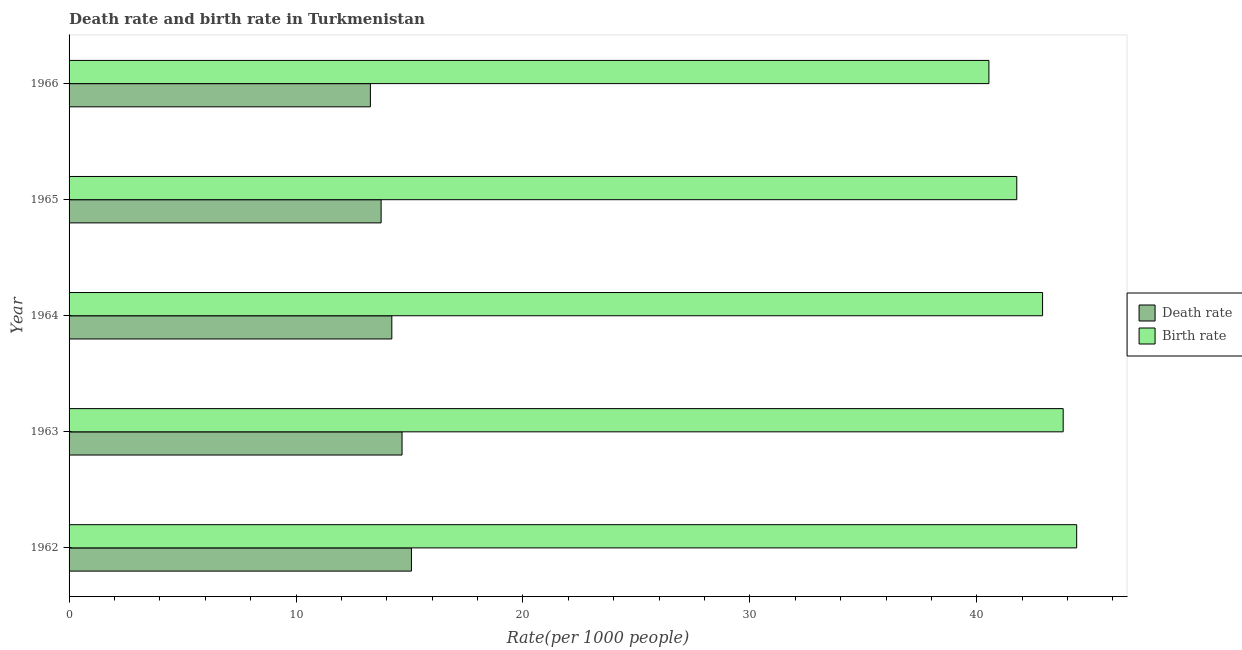How many groups of bars are there?
Make the answer very short. 5. How many bars are there on the 5th tick from the bottom?
Ensure brevity in your answer.  2. What is the label of the 3rd group of bars from the top?
Provide a short and direct response. 1964. What is the death rate in 1965?
Your answer should be compact. 13.75. Across all years, what is the maximum death rate?
Keep it short and to the point. 15.09. Across all years, what is the minimum birth rate?
Keep it short and to the point. 40.53. In which year was the death rate minimum?
Your answer should be compact. 1966. What is the total death rate in the graph?
Provide a short and direct response. 71.01. What is the difference between the death rate in 1963 and that in 1964?
Provide a succinct answer. 0.45. What is the difference between the death rate in 1962 and the birth rate in 1964?
Offer a very short reply. -27.81. What is the average death rate per year?
Your answer should be compact. 14.2. In the year 1965, what is the difference between the death rate and birth rate?
Your answer should be very brief. -28.01. In how many years, is the death rate greater than 42 ?
Ensure brevity in your answer.  0. What is the ratio of the death rate in 1965 to that in 1966?
Your answer should be very brief. 1.04. Is the birth rate in 1962 less than that in 1963?
Your response must be concise. No. Is the difference between the birth rate in 1962 and 1964 greater than the difference between the death rate in 1962 and 1964?
Offer a very short reply. Yes. What is the difference between the highest and the second highest birth rate?
Ensure brevity in your answer.  0.59. What is the difference between the highest and the lowest death rate?
Your response must be concise. 1.81. What does the 2nd bar from the top in 1966 represents?
Your response must be concise. Death rate. What does the 1st bar from the bottom in 1966 represents?
Make the answer very short. Death rate. How many bars are there?
Keep it short and to the point. 10. Are all the bars in the graph horizontal?
Provide a succinct answer. Yes. How many years are there in the graph?
Ensure brevity in your answer.  5. Does the graph contain any zero values?
Keep it short and to the point. No. Does the graph contain grids?
Offer a very short reply. No. How many legend labels are there?
Your response must be concise. 2. What is the title of the graph?
Your answer should be compact. Death rate and birth rate in Turkmenistan. Does "Investment in Transport" appear as one of the legend labels in the graph?
Provide a succinct answer. No. What is the label or title of the X-axis?
Your answer should be compact. Rate(per 1000 people). What is the Rate(per 1000 people) of Death rate in 1962?
Your answer should be very brief. 15.09. What is the Rate(per 1000 people) of Birth rate in 1962?
Keep it short and to the point. 44.4. What is the Rate(per 1000 people) in Death rate in 1963?
Keep it short and to the point. 14.67. What is the Rate(per 1000 people) of Birth rate in 1963?
Your response must be concise. 43.81. What is the Rate(per 1000 people) in Death rate in 1964?
Your answer should be compact. 14.22. What is the Rate(per 1000 people) in Birth rate in 1964?
Your answer should be compact. 42.9. What is the Rate(per 1000 people) of Death rate in 1965?
Provide a short and direct response. 13.75. What is the Rate(per 1000 people) of Birth rate in 1965?
Offer a very short reply. 41.76. What is the Rate(per 1000 people) of Death rate in 1966?
Ensure brevity in your answer.  13.28. What is the Rate(per 1000 people) in Birth rate in 1966?
Provide a short and direct response. 40.53. Across all years, what is the maximum Rate(per 1000 people) in Death rate?
Provide a short and direct response. 15.09. Across all years, what is the maximum Rate(per 1000 people) of Birth rate?
Your response must be concise. 44.4. Across all years, what is the minimum Rate(per 1000 people) in Death rate?
Provide a short and direct response. 13.28. Across all years, what is the minimum Rate(per 1000 people) in Birth rate?
Keep it short and to the point. 40.53. What is the total Rate(per 1000 people) of Death rate in the graph?
Provide a short and direct response. 71.01. What is the total Rate(per 1000 people) in Birth rate in the graph?
Give a very brief answer. 213.4. What is the difference between the Rate(per 1000 people) in Death rate in 1962 and that in 1963?
Ensure brevity in your answer.  0.41. What is the difference between the Rate(per 1000 people) in Birth rate in 1962 and that in 1963?
Offer a very short reply. 0.59. What is the difference between the Rate(per 1000 people) of Death rate in 1962 and that in 1964?
Your response must be concise. 0.86. What is the difference between the Rate(per 1000 people) in Birth rate in 1962 and that in 1964?
Offer a very short reply. 1.5. What is the difference between the Rate(per 1000 people) in Death rate in 1962 and that in 1965?
Provide a succinct answer. 1.34. What is the difference between the Rate(per 1000 people) in Birth rate in 1962 and that in 1965?
Your answer should be compact. 2.64. What is the difference between the Rate(per 1000 people) in Death rate in 1962 and that in 1966?
Offer a terse response. 1.81. What is the difference between the Rate(per 1000 people) in Birth rate in 1962 and that in 1966?
Make the answer very short. 3.87. What is the difference between the Rate(per 1000 people) in Death rate in 1963 and that in 1964?
Give a very brief answer. 0.45. What is the difference between the Rate(per 1000 people) of Birth rate in 1963 and that in 1964?
Make the answer very short. 0.91. What is the difference between the Rate(per 1000 people) of Death rate in 1963 and that in 1965?
Provide a short and direct response. 0.92. What is the difference between the Rate(per 1000 people) in Birth rate in 1963 and that in 1965?
Your answer should be compact. 2.04. What is the difference between the Rate(per 1000 people) in Death rate in 1963 and that in 1966?
Provide a succinct answer. 1.4. What is the difference between the Rate(per 1000 people) in Birth rate in 1963 and that in 1966?
Your answer should be compact. 3.27. What is the difference between the Rate(per 1000 people) in Death rate in 1964 and that in 1965?
Give a very brief answer. 0.47. What is the difference between the Rate(per 1000 people) of Birth rate in 1964 and that in 1965?
Your response must be concise. 1.14. What is the difference between the Rate(per 1000 people) of Death rate in 1964 and that in 1966?
Your answer should be very brief. 0.94. What is the difference between the Rate(per 1000 people) of Birth rate in 1964 and that in 1966?
Offer a very short reply. 2.37. What is the difference between the Rate(per 1000 people) in Death rate in 1965 and that in 1966?
Provide a short and direct response. 0.47. What is the difference between the Rate(per 1000 people) in Birth rate in 1965 and that in 1966?
Keep it short and to the point. 1.23. What is the difference between the Rate(per 1000 people) of Death rate in 1962 and the Rate(per 1000 people) of Birth rate in 1963?
Give a very brief answer. -28.72. What is the difference between the Rate(per 1000 people) in Death rate in 1962 and the Rate(per 1000 people) in Birth rate in 1964?
Offer a very short reply. -27.81. What is the difference between the Rate(per 1000 people) of Death rate in 1962 and the Rate(per 1000 people) of Birth rate in 1965?
Provide a succinct answer. -26.68. What is the difference between the Rate(per 1000 people) of Death rate in 1962 and the Rate(per 1000 people) of Birth rate in 1966?
Provide a succinct answer. -25.45. What is the difference between the Rate(per 1000 people) of Death rate in 1963 and the Rate(per 1000 people) of Birth rate in 1964?
Keep it short and to the point. -28.23. What is the difference between the Rate(per 1000 people) in Death rate in 1963 and the Rate(per 1000 people) in Birth rate in 1965?
Ensure brevity in your answer.  -27.09. What is the difference between the Rate(per 1000 people) of Death rate in 1963 and the Rate(per 1000 people) of Birth rate in 1966?
Give a very brief answer. -25.86. What is the difference between the Rate(per 1000 people) of Death rate in 1964 and the Rate(per 1000 people) of Birth rate in 1965?
Ensure brevity in your answer.  -27.54. What is the difference between the Rate(per 1000 people) in Death rate in 1964 and the Rate(per 1000 people) in Birth rate in 1966?
Ensure brevity in your answer.  -26.31. What is the difference between the Rate(per 1000 people) in Death rate in 1965 and the Rate(per 1000 people) in Birth rate in 1966?
Your answer should be very brief. -26.78. What is the average Rate(per 1000 people) in Death rate per year?
Give a very brief answer. 14.2. What is the average Rate(per 1000 people) of Birth rate per year?
Keep it short and to the point. 42.68. In the year 1962, what is the difference between the Rate(per 1000 people) of Death rate and Rate(per 1000 people) of Birth rate?
Provide a succinct answer. -29.32. In the year 1963, what is the difference between the Rate(per 1000 people) in Death rate and Rate(per 1000 people) in Birth rate?
Provide a short and direct response. -29.13. In the year 1964, what is the difference between the Rate(per 1000 people) in Death rate and Rate(per 1000 people) in Birth rate?
Provide a succinct answer. -28.68. In the year 1965, what is the difference between the Rate(per 1000 people) in Death rate and Rate(per 1000 people) in Birth rate?
Give a very brief answer. -28.01. In the year 1966, what is the difference between the Rate(per 1000 people) in Death rate and Rate(per 1000 people) in Birth rate?
Give a very brief answer. -27.26. What is the ratio of the Rate(per 1000 people) of Death rate in 1962 to that in 1963?
Give a very brief answer. 1.03. What is the ratio of the Rate(per 1000 people) in Birth rate in 1962 to that in 1963?
Offer a very short reply. 1.01. What is the ratio of the Rate(per 1000 people) in Death rate in 1962 to that in 1964?
Your answer should be compact. 1.06. What is the ratio of the Rate(per 1000 people) in Birth rate in 1962 to that in 1964?
Your response must be concise. 1.03. What is the ratio of the Rate(per 1000 people) of Death rate in 1962 to that in 1965?
Provide a succinct answer. 1.1. What is the ratio of the Rate(per 1000 people) of Birth rate in 1962 to that in 1965?
Keep it short and to the point. 1.06. What is the ratio of the Rate(per 1000 people) in Death rate in 1962 to that in 1966?
Provide a short and direct response. 1.14. What is the ratio of the Rate(per 1000 people) in Birth rate in 1962 to that in 1966?
Your answer should be very brief. 1.1. What is the ratio of the Rate(per 1000 people) of Death rate in 1963 to that in 1964?
Your response must be concise. 1.03. What is the ratio of the Rate(per 1000 people) in Birth rate in 1963 to that in 1964?
Keep it short and to the point. 1.02. What is the ratio of the Rate(per 1000 people) in Death rate in 1963 to that in 1965?
Your answer should be compact. 1.07. What is the ratio of the Rate(per 1000 people) in Birth rate in 1963 to that in 1965?
Your answer should be compact. 1.05. What is the ratio of the Rate(per 1000 people) in Death rate in 1963 to that in 1966?
Provide a succinct answer. 1.11. What is the ratio of the Rate(per 1000 people) of Birth rate in 1963 to that in 1966?
Ensure brevity in your answer.  1.08. What is the ratio of the Rate(per 1000 people) in Death rate in 1964 to that in 1965?
Offer a terse response. 1.03. What is the ratio of the Rate(per 1000 people) of Birth rate in 1964 to that in 1965?
Offer a very short reply. 1.03. What is the ratio of the Rate(per 1000 people) of Death rate in 1964 to that in 1966?
Ensure brevity in your answer.  1.07. What is the ratio of the Rate(per 1000 people) in Birth rate in 1964 to that in 1966?
Provide a succinct answer. 1.06. What is the ratio of the Rate(per 1000 people) in Death rate in 1965 to that in 1966?
Your answer should be very brief. 1.04. What is the ratio of the Rate(per 1000 people) of Birth rate in 1965 to that in 1966?
Provide a short and direct response. 1.03. What is the difference between the highest and the second highest Rate(per 1000 people) of Death rate?
Give a very brief answer. 0.41. What is the difference between the highest and the second highest Rate(per 1000 people) in Birth rate?
Provide a succinct answer. 0.59. What is the difference between the highest and the lowest Rate(per 1000 people) in Death rate?
Ensure brevity in your answer.  1.81. What is the difference between the highest and the lowest Rate(per 1000 people) in Birth rate?
Provide a succinct answer. 3.87. 